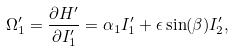<formula> <loc_0><loc_0><loc_500><loc_500>\Omega _ { 1 } ^ { \prime } = \frac { \partial H ^ { \prime } } { \partial I _ { 1 } ^ { \prime } } = \alpha _ { 1 } I _ { 1 } ^ { \prime } + \epsilon \sin ( \beta ) I _ { 2 } ^ { \prime } ,</formula> 